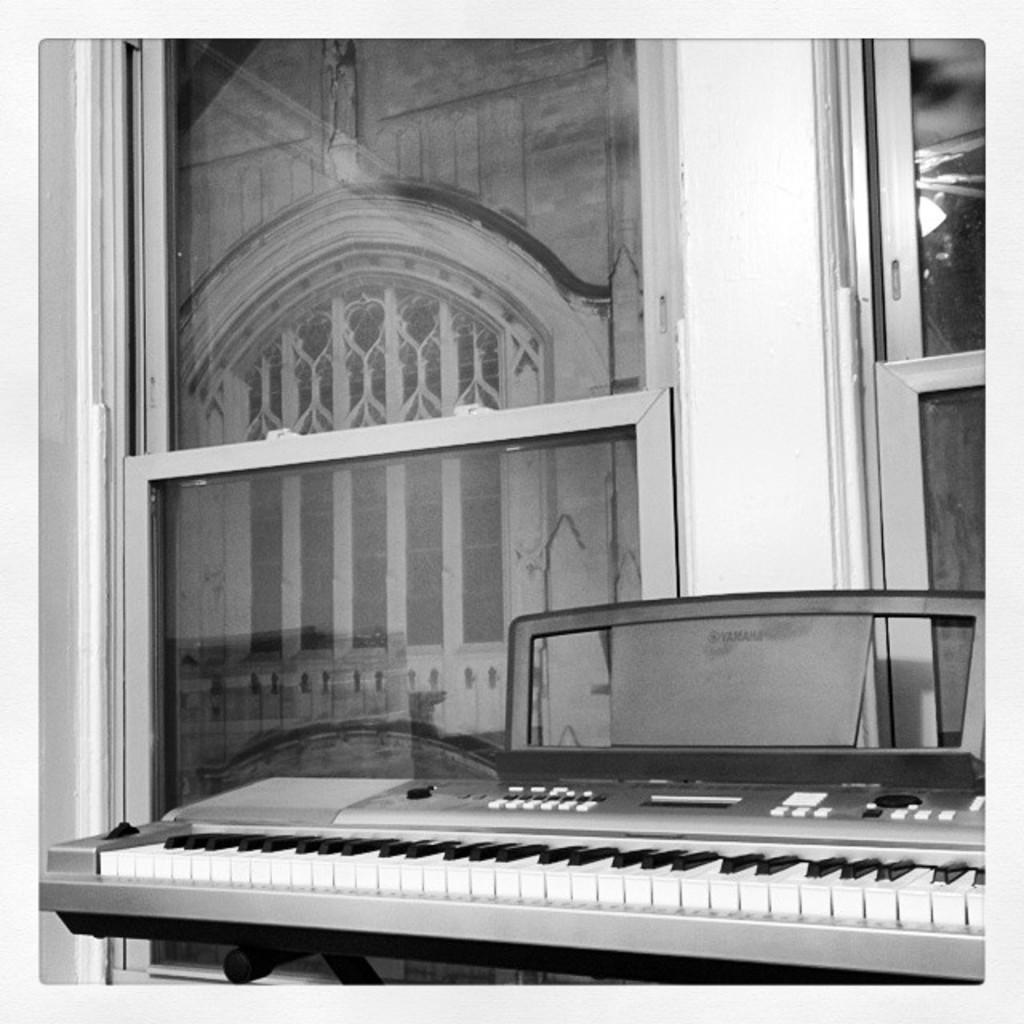What electronic device is present in the image? There is a Casio in the image. How is the Casio positioned in the image? The Casio is kept on a stand. What can be seen in the background of the image? There is a building visible in the background of the image. What feature of the building is mentioned in the image? The building has a window. What color scheme is used in the image? The image is in black and white color. What type of horse can be seen playing during recess in the image? There is no horse or recess mentioned in the image. 